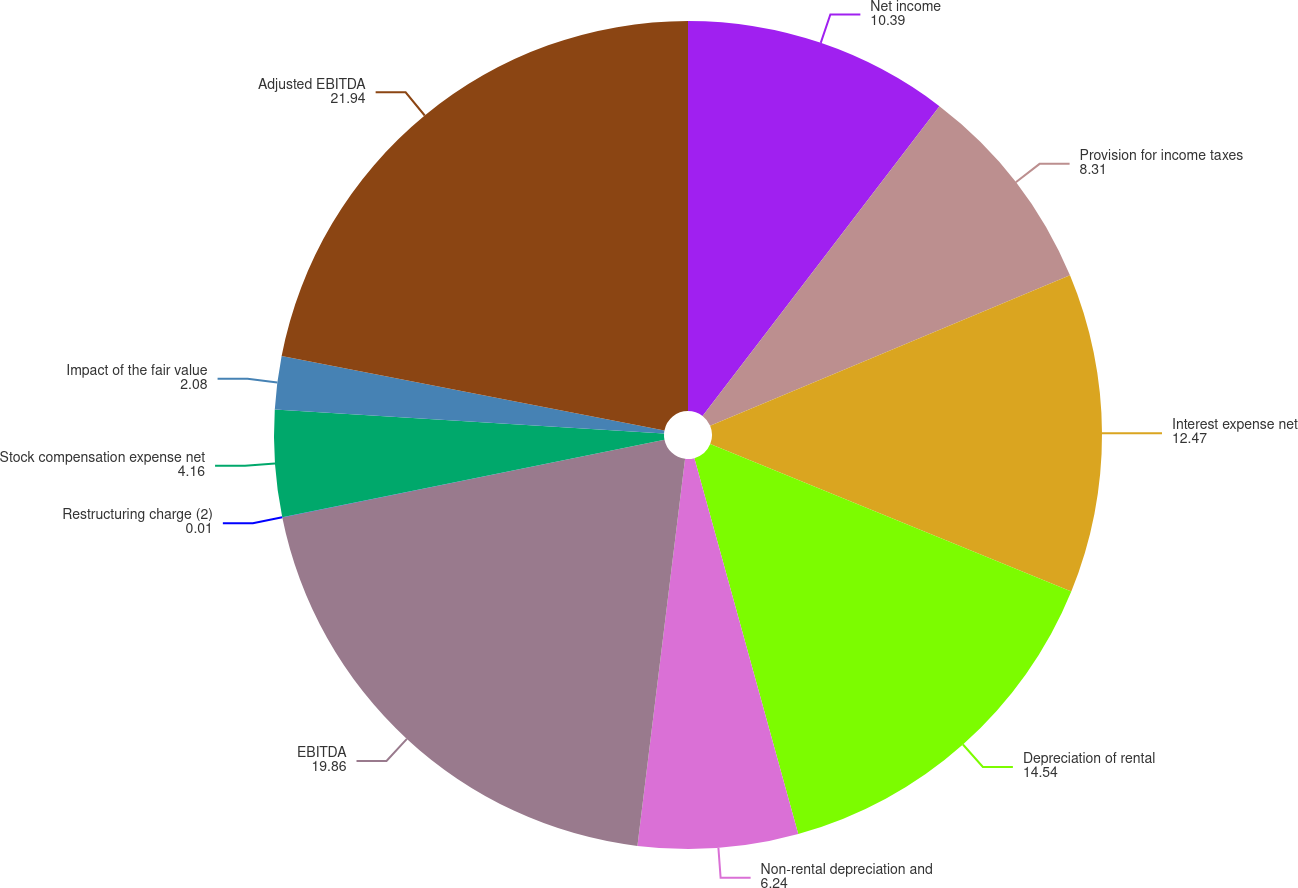Convert chart to OTSL. <chart><loc_0><loc_0><loc_500><loc_500><pie_chart><fcel>Net income<fcel>Provision for income taxes<fcel>Interest expense net<fcel>Depreciation of rental<fcel>Non-rental depreciation and<fcel>EBITDA<fcel>Restructuring charge (2)<fcel>Stock compensation expense net<fcel>Impact of the fair value<fcel>Adjusted EBITDA<nl><fcel>10.39%<fcel>8.31%<fcel>12.47%<fcel>14.54%<fcel>6.24%<fcel>19.86%<fcel>0.01%<fcel>4.16%<fcel>2.08%<fcel>21.94%<nl></chart> 